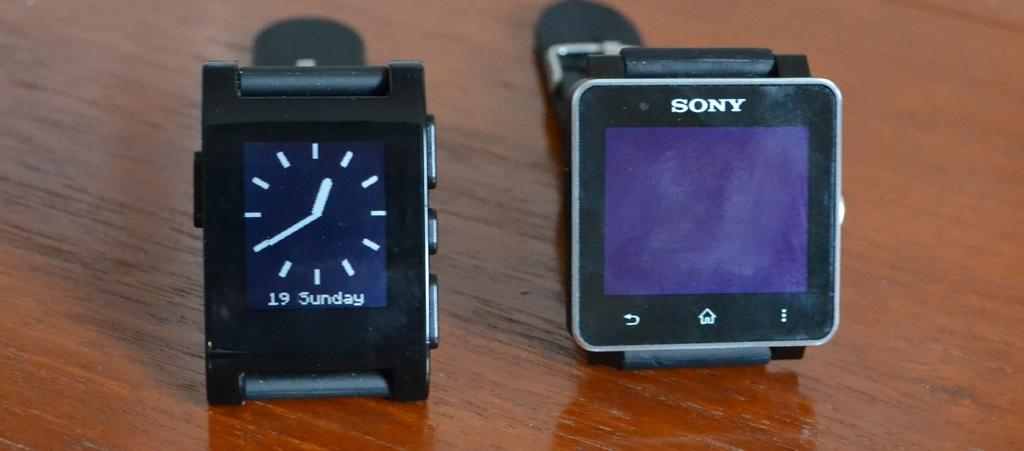What objects are present in the image? There are two watches in the image. Where are the watches placed? The watches are on a wooden surface. What type of kitty can be seen playing with the watches in the image? There is no kitty present in the image, and therefore no such activity can be observed. What type of band is playing with the watches in the image? There is no band present in the image, and the watches are simply placed on a wooden surface. 